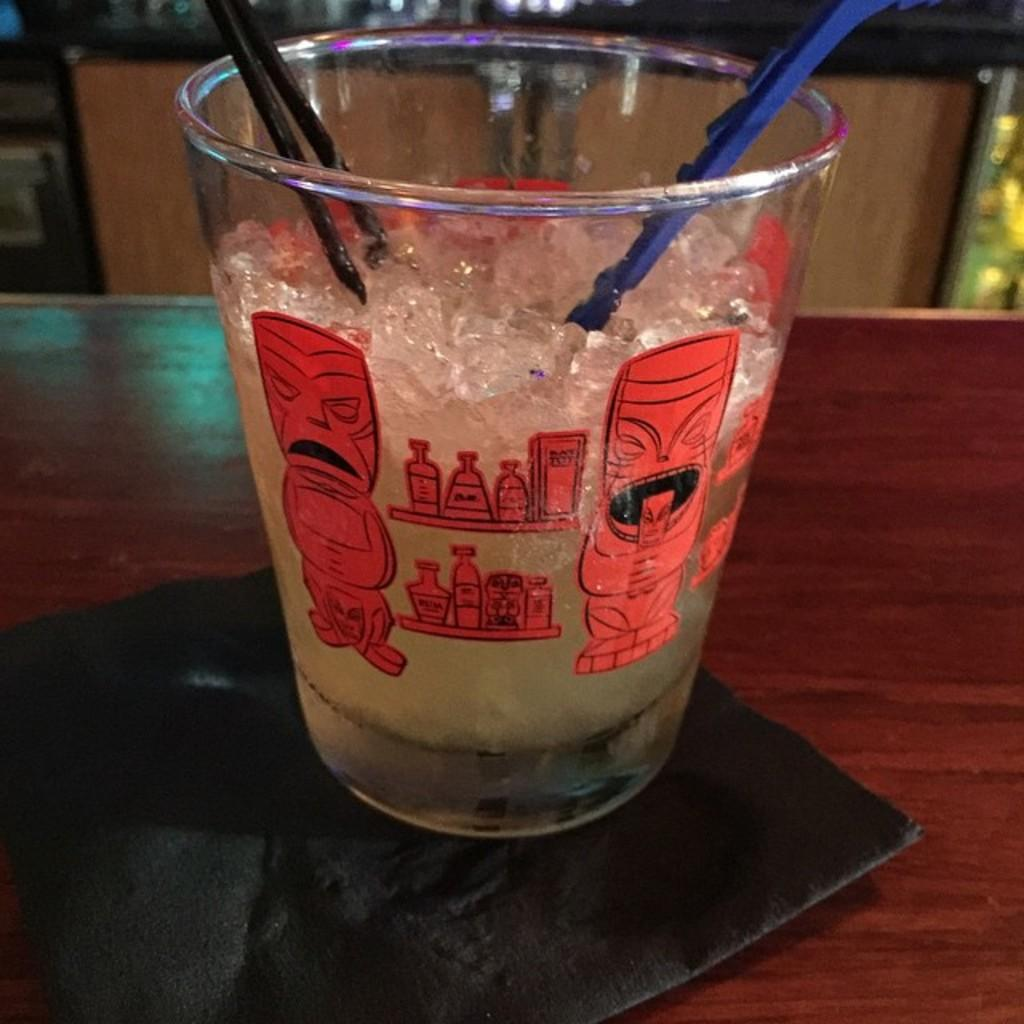What is in the glass that is visible in the image? There is a glass with ice in the image. What is inside the glass with the ice? There are straws in the glass. Where is the glass located in the image? The glass is on a table. Can you describe the background of the image? The background of the image is blurry. What type of ghost can be seen interacting with the glass in the image? There is no ghost present in the image; it only features a glass with ice and straws on a table. What kind of soap is used to clean the table in the image? There is no soap or cleaning activity depicted in the image; it only shows a glass with ice and straws on a table. 